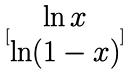Convert formula to latex. <formula><loc_0><loc_0><loc_500><loc_500>[ \begin{matrix} \ln x \\ \ln ( 1 - x ) \end{matrix} ]</formula> 